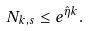Convert formula to latex. <formula><loc_0><loc_0><loc_500><loc_500>N _ { k , s } \leq e ^ { \hat { \eta } k } .</formula> 